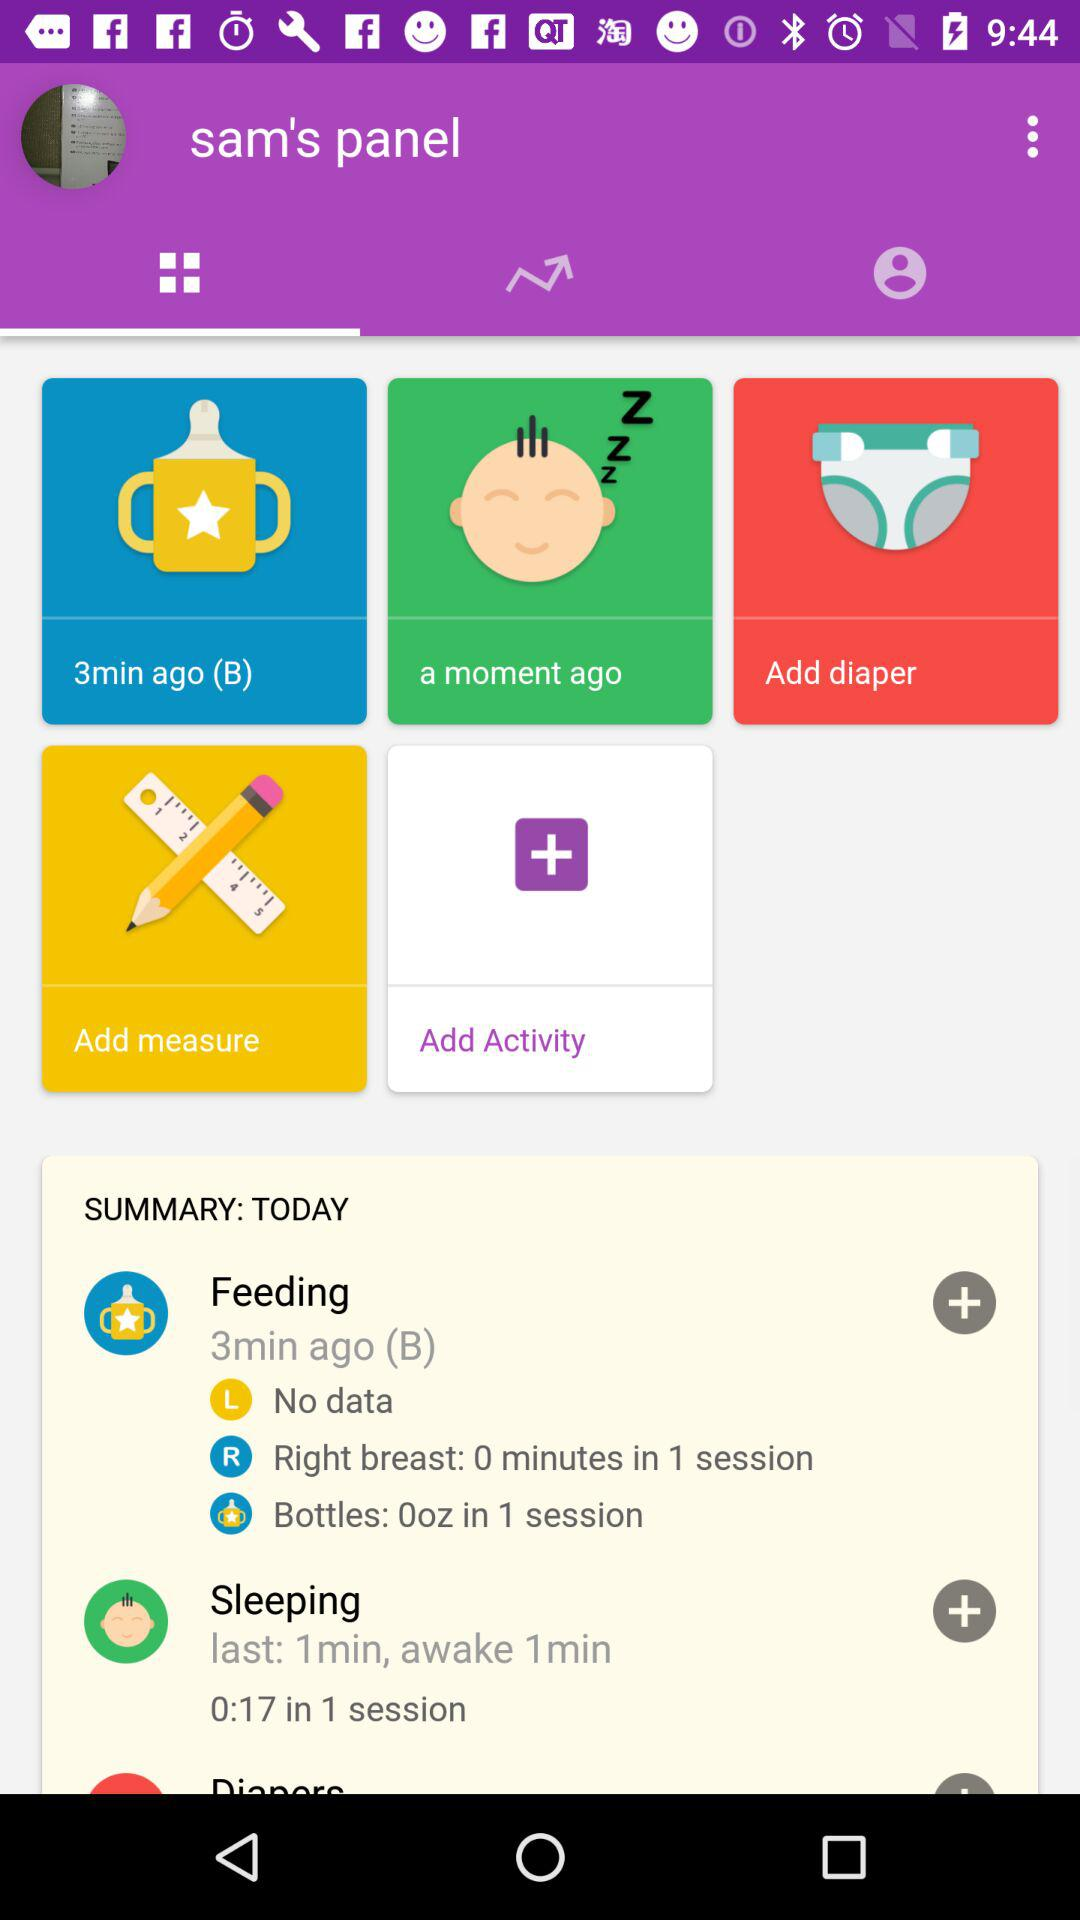What is the duration of sleep time in 1 session? The duration is 0:17 seconds. 